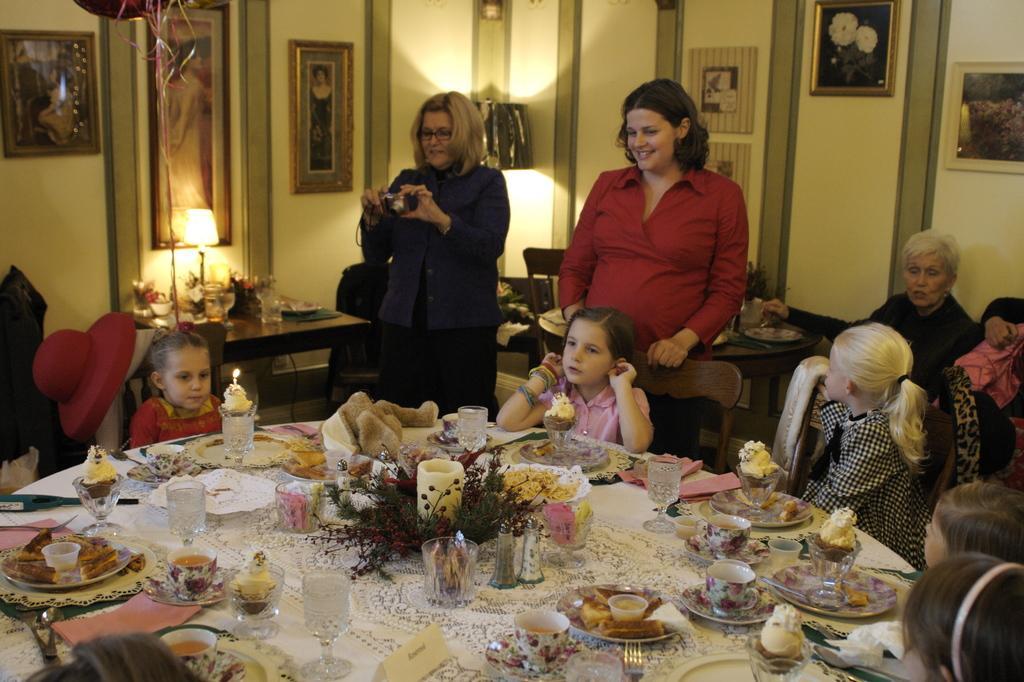Could you give a brief overview of what you see in this image? In this picture there are group of people sitting in the chair. There is a glass, candle, cup ,food in plate, name plate, saucer,bread other items on table. There is a lamp, glass, bowl on the table. There are frames on the wall. There are two women who are standing. There is a camera. There is a woman sitting on the chair. 